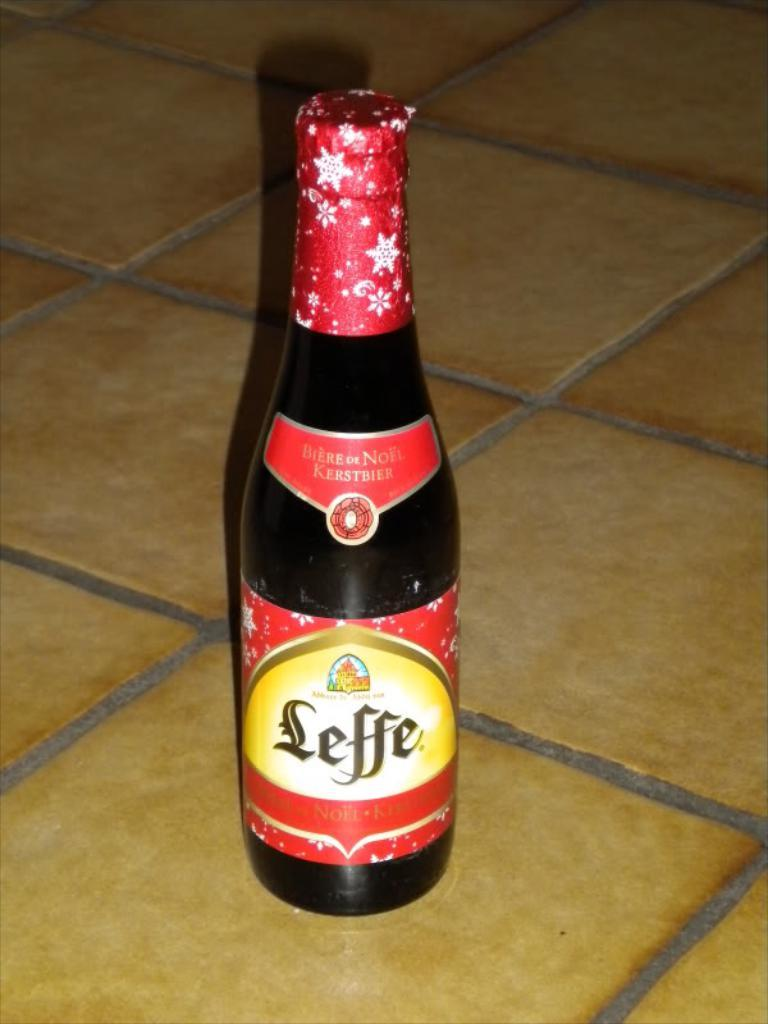<image>
Summarize the visual content of the image. The band on the neck of a beer bottle says it is "biere de noel". 